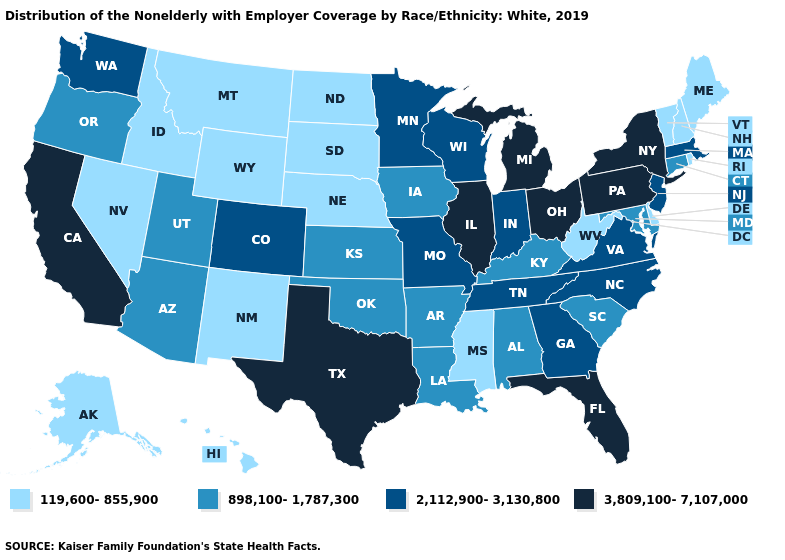Does Rhode Island have the same value as Nevada?
Concise answer only. Yes. Name the states that have a value in the range 3,809,100-7,107,000?
Write a very short answer. California, Florida, Illinois, Michigan, New York, Ohio, Pennsylvania, Texas. What is the highest value in the MidWest ?
Write a very short answer. 3,809,100-7,107,000. Does Florida have the highest value in the USA?
Concise answer only. Yes. Name the states that have a value in the range 898,100-1,787,300?
Concise answer only. Alabama, Arizona, Arkansas, Connecticut, Iowa, Kansas, Kentucky, Louisiana, Maryland, Oklahoma, Oregon, South Carolina, Utah. Does Indiana have a lower value than Ohio?
Short answer required. Yes. Among the states that border Oregon , does California have the lowest value?
Answer briefly. No. Name the states that have a value in the range 2,112,900-3,130,800?
Write a very short answer. Colorado, Georgia, Indiana, Massachusetts, Minnesota, Missouri, New Jersey, North Carolina, Tennessee, Virginia, Washington, Wisconsin. What is the value of Arizona?
Write a very short answer. 898,100-1,787,300. What is the value of Colorado?
Write a very short answer. 2,112,900-3,130,800. Name the states that have a value in the range 2,112,900-3,130,800?
Keep it brief. Colorado, Georgia, Indiana, Massachusetts, Minnesota, Missouri, New Jersey, North Carolina, Tennessee, Virginia, Washington, Wisconsin. Is the legend a continuous bar?
Short answer required. No. Among the states that border New Jersey , does New York have the lowest value?
Concise answer only. No. Which states have the lowest value in the USA?
Concise answer only. Alaska, Delaware, Hawaii, Idaho, Maine, Mississippi, Montana, Nebraska, Nevada, New Hampshire, New Mexico, North Dakota, Rhode Island, South Dakota, Vermont, West Virginia, Wyoming. Among the states that border New Hampshire , which have the lowest value?
Quick response, please. Maine, Vermont. 